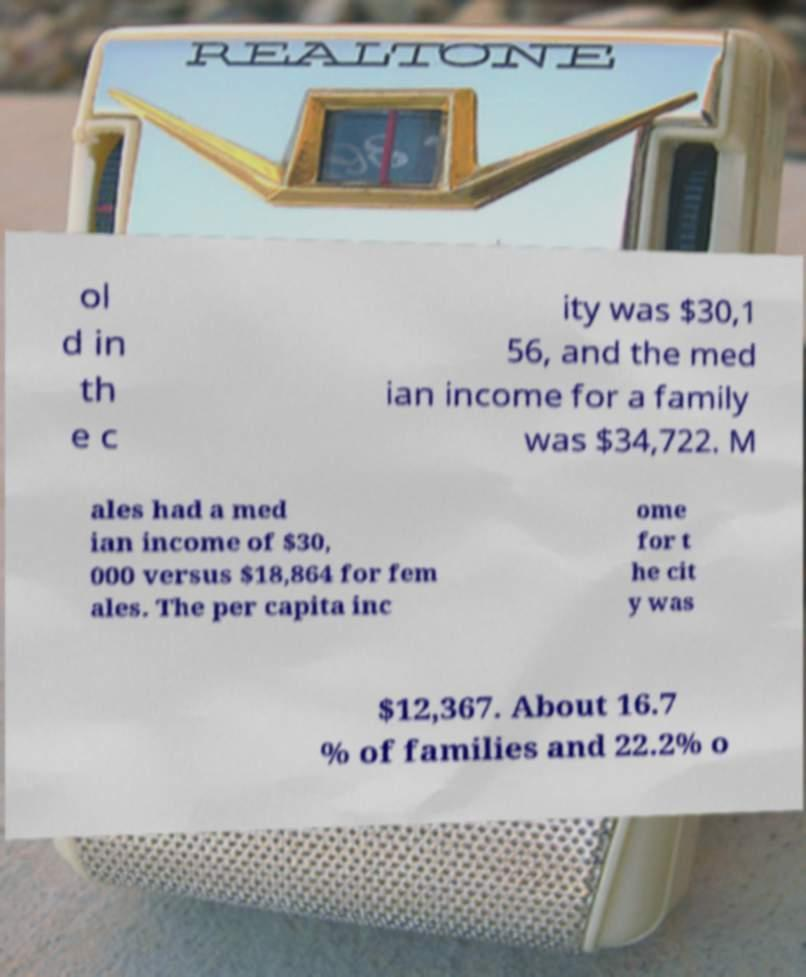Please read and relay the text visible in this image. What does it say? ol d in th e c ity was $30,1 56, and the med ian income for a family was $34,722. M ales had a med ian income of $30, 000 versus $18,864 for fem ales. The per capita inc ome for t he cit y was $12,367. About 16.7 % of families and 22.2% o 